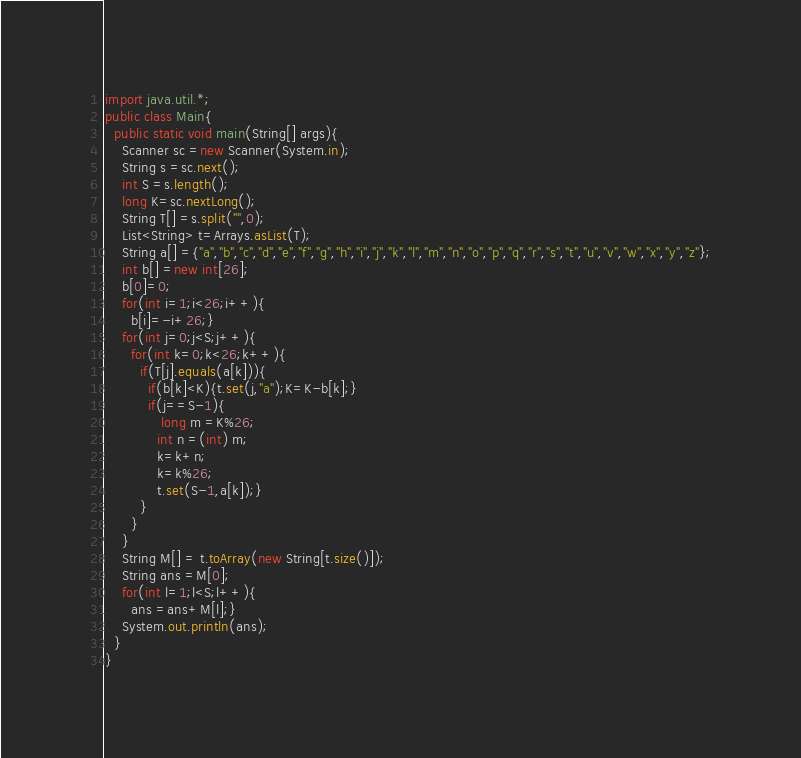<code> <loc_0><loc_0><loc_500><loc_500><_Java_>import java.util.*;
public class Main{
  public static void main(String[] args){
    Scanner sc =new Scanner(System.in);
    String s =sc.next();
    int S =s.length();
    long K=sc.nextLong();
    String T[] =s.split("",0);
    List<String> t=Arrays.asList(T);
    String a[] ={"a","b","c","d","e","f","g","h","i","j","k","l","m","n","o","p","q","r","s","t","u","v","w","x","y","z"};
    int b[] =new int[26];
    b[0]=0;
    for(int i=1;i<26;i++){
      b[i]=-i+26;}
    for(int j=0;j<S;j++){
      for(int k=0;k<26;k++){
        if(T[j].equals(a[k])){
          if(b[k]<K){t.set(j,"a");K=K-b[k];}
          if(j==S-1){
             long m =K%26;
            int n =(int) m;
            k=k+n;
            k=k%26;
            t.set(S-1,a[k]);}
        }
      }
    }
    String M[] = t.toArray(new String[t.size()]);
    String ans =M[0];
    for(int l=1;l<S;l++){
      ans =ans+M[l];}
    System.out.println(ans);
  }
}</code> 